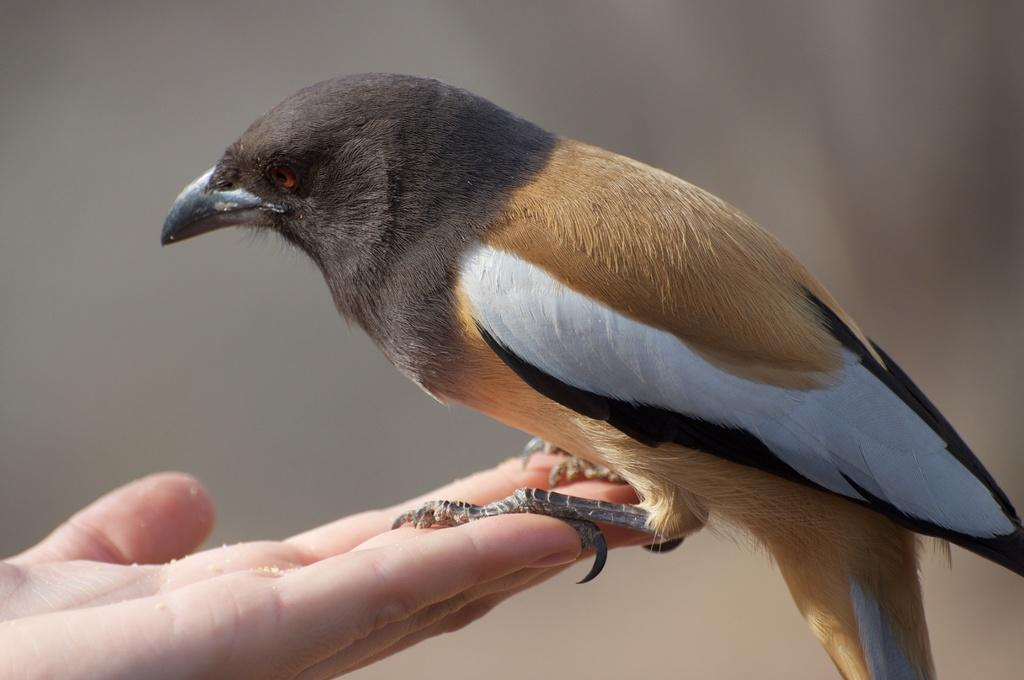What type of animal is in the image? There is a bird in the image. Where is the bird located in the image? The bird is on a hand. Can you describe the background of the image? The background of the image is blurred. What type of minister is visible in the image? There is no minister present in the image; it features a bird on a hand with a blurred background. 